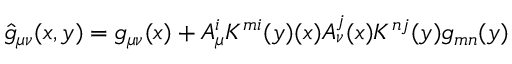<formula> <loc_0><loc_0><loc_500><loc_500>{ \hat { g } } _ { \mu \nu } ( x , y ) = g _ { \mu \nu } ( x ) + A _ { \mu } ^ { i } K ^ { m i } ( y ) ( x ) A _ { \nu } ^ { j } ( x ) K ^ { n j } ( y ) g _ { m n } ( y )</formula> 